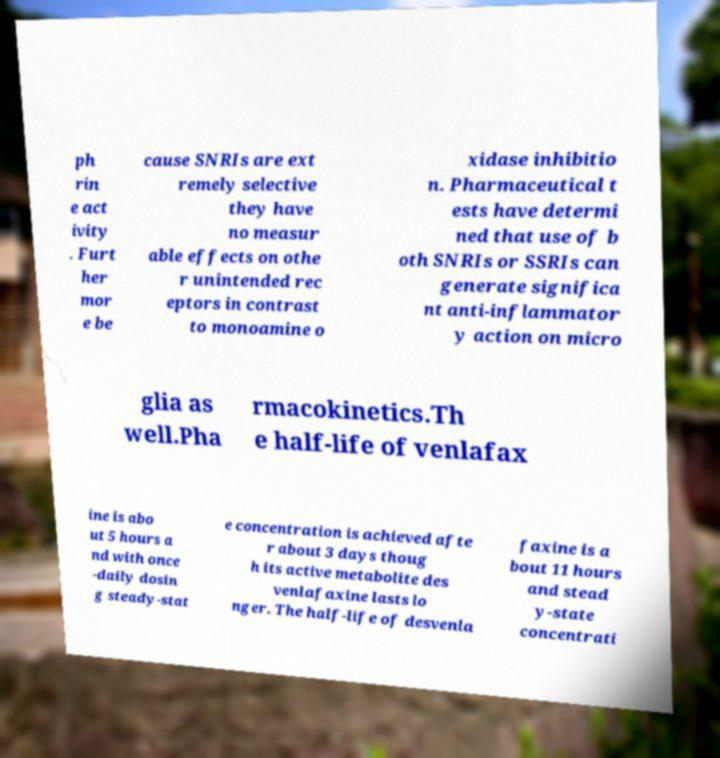Can you accurately transcribe the text from the provided image for me? ph rin e act ivity . Furt her mor e be cause SNRIs are ext remely selective they have no measur able effects on othe r unintended rec eptors in contrast to monoamine o xidase inhibitio n. Pharmaceutical t ests have determi ned that use of b oth SNRIs or SSRIs can generate significa nt anti-inflammator y action on micro glia as well.Pha rmacokinetics.Th e half-life of venlafax ine is abo ut 5 hours a nd with once -daily dosin g steady-stat e concentration is achieved afte r about 3 days thoug h its active metabolite des venlafaxine lasts lo nger. The half-life of desvenla faxine is a bout 11 hours and stead y-state concentrati 